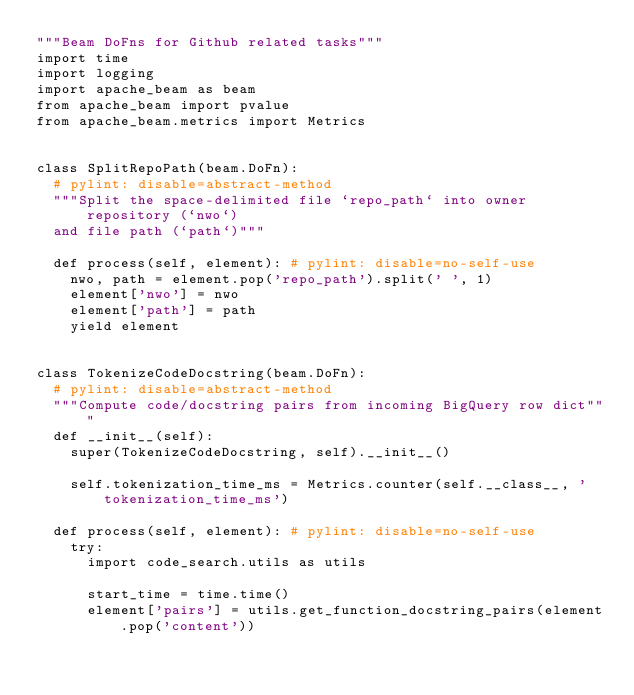<code> <loc_0><loc_0><loc_500><loc_500><_Python_>"""Beam DoFns for Github related tasks"""
import time
import logging
import apache_beam as beam
from apache_beam import pvalue
from apache_beam.metrics import Metrics


class SplitRepoPath(beam.DoFn):
  # pylint: disable=abstract-method
  """Split the space-delimited file `repo_path` into owner repository (`nwo`)
  and file path (`path`)"""

  def process(self, element): # pylint: disable=no-self-use
    nwo, path = element.pop('repo_path').split(' ', 1)
    element['nwo'] = nwo
    element['path'] = path
    yield element


class TokenizeCodeDocstring(beam.DoFn):
  # pylint: disable=abstract-method
  """Compute code/docstring pairs from incoming BigQuery row dict"""
  def __init__(self):
    super(TokenizeCodeDocstring, self).__init__()

    self.tokenization_time_ms = Metrics.counter(self.__class__, 'tokenization_time_ms')

  def process(self, element): # pylint: disable=no-self-use
    try:
      import code_search.utils as utils

      start_time = time.time()
      element['pairs'] = utils.get_function_docstring_pairs(element.pop('content'))</code> 